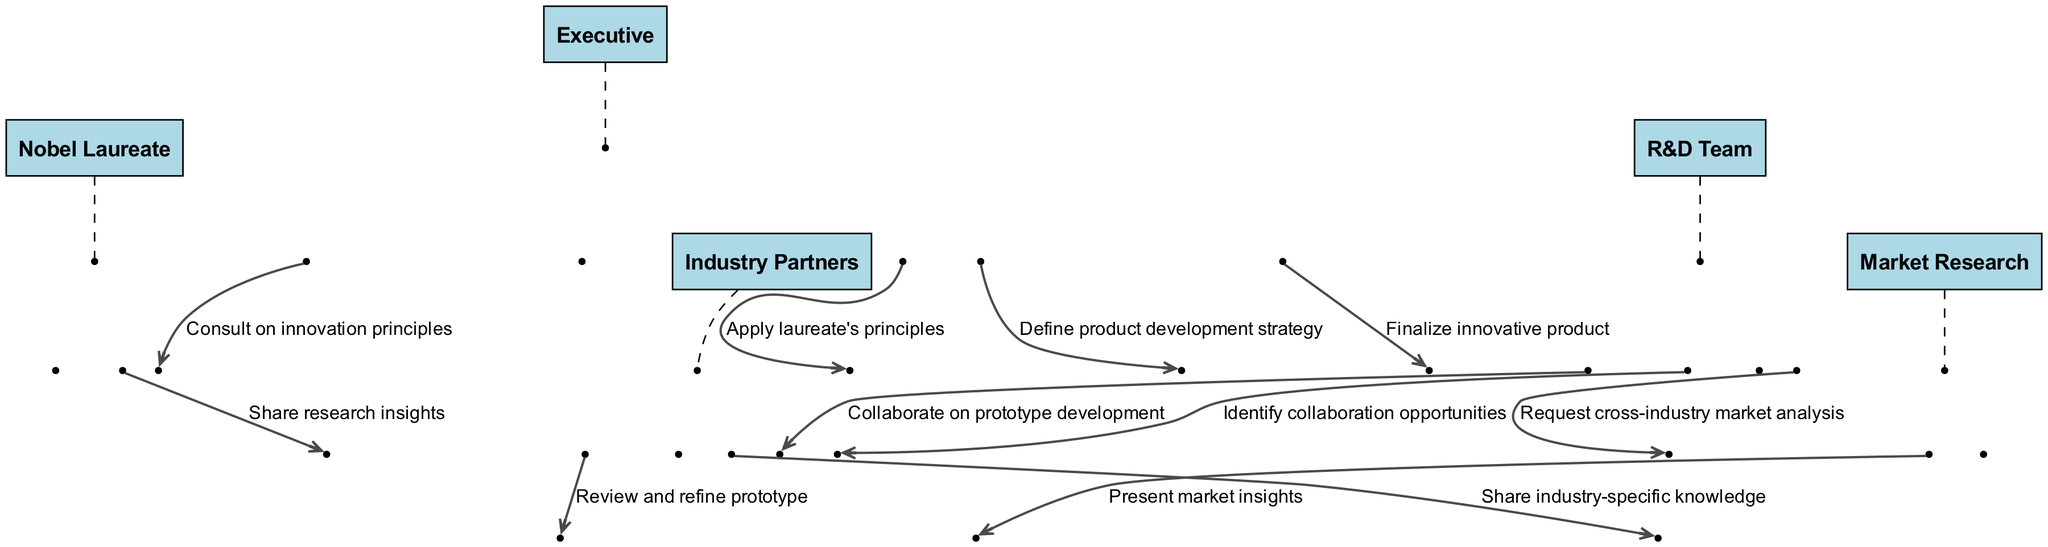What is the first message exchanged in the diagram? The first message in the sequence diagram is exchanged from the Executive to the Nobel Laureate, indicating a consultation on innovation principles. This can be identified as the very first step in the sequence flow.
Answer: Consult on innovation principles How many actors are involved in the collaboration process? By counting the distinct actors listed in the diagram, we find there are five actors: Executive, Nobel Laureate, R&D Team, Industry Partners, and Market Research.
Answer: 5 Which actor receives the market insights? The Market Research actor presents market insights to the Executive, based on the interaction shown in the sequence flow that connects these two actors.
Answer: Executive What is the main purpose of the R&D Team's message to Industry Partners? The R&D Team sends a message to the Industry Partners to identify potential collaboration opportunities. This indicates the R&D Team's proactive approach towards fostering innovation through external partnerships.
Answer: Identify collaboration opportunities Who defines the product development strategy? The person responsible for defining the product development strategy is the Executive, as indicated by the specific message in the diagram that flows from the Executive to the R&D Team.
Answer: Executive What step comes after the R&D Team collaborates on prototype development? After the R&D Team collaborates on prototype development, the Industry Partners then review and refine the prototype, as seen in the sequence following the prototype development step.
Answer: Review and refine prototype Which actor is responsible for requesting a cross-industry market analysis? The R&D Team is the actor responsible for sending a request for a cross-industry market analysis to the Market Research actor, reflecting the collaborative nature of the process for product development insights.
Answer: R&D Team What type of knowledge do Industry Partners share with the R&D Team? The Industry Partners share industry-specific knowledge with the R&D Team, which is a crucial part of the collaboration exchange process illustrated in the diagram.
Answer: Share industry-specific knowledge What is the final step of the collaboration process? The last step shown in the sequence diagram is the Executive finalizing the innovative product after all prior collaboration steps and developments have taken place.
Answer: Finalize innovative product 